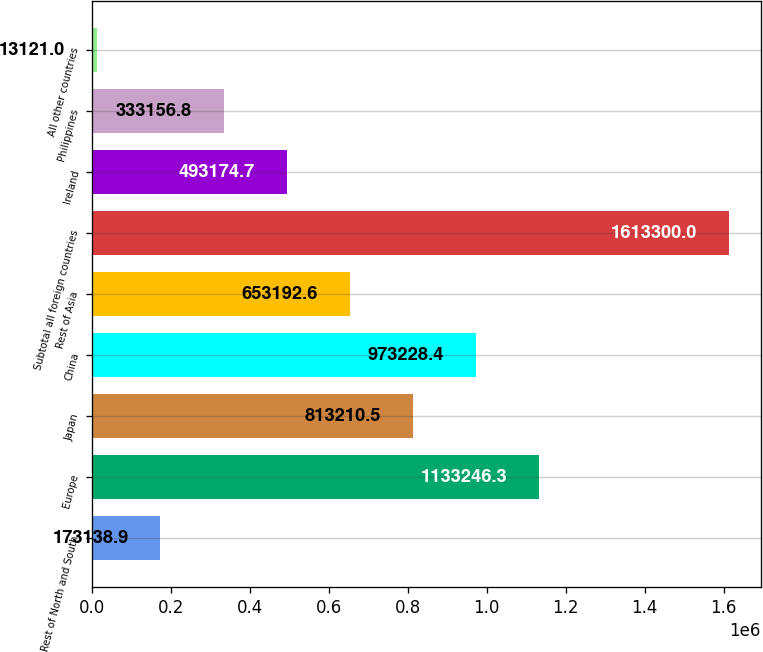Convert chart to OTSL. <chart><loc_0><loc_0><loc_500><loc_500><bar_chart><fcel>Rest of North and South<fcel>Europe<fcel>Japan<fcel>China<fcel>Rest of Asia<fcel>Subtotal all foreign countries<fcel>Ireland<fcel>Philippines<fcel>All other countries<nl><fcel>173139<fcel>1.13325e+06<fcel>813210<fcel>973228<fcel>653193<fcel>1.6133e+06<fcel>493175<fcel>333157<fcel>13121<nl></chart> 